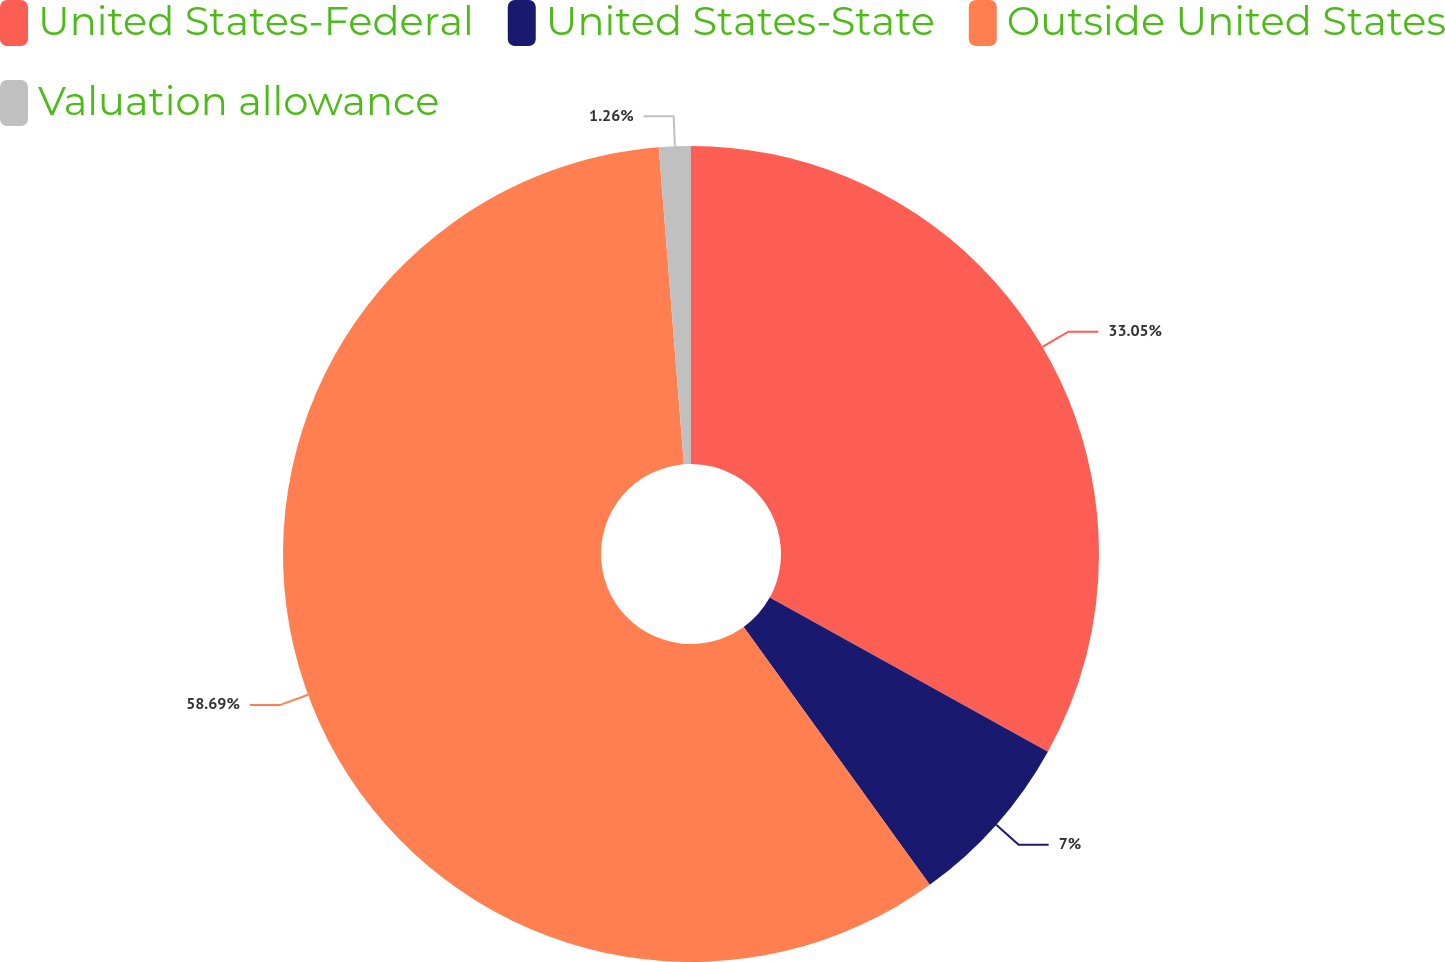<chart> <loc_0><loc_0><loc_500><loc_500><pie_chart><fcel>United States-Federal<fcel>United States-State<fcel>Outside United States<fcel>Valuation allowance<nl><fcel>33.05%<fcel>7.0%<fcel>58.69%<fcel>1.26%<nl></chart> 